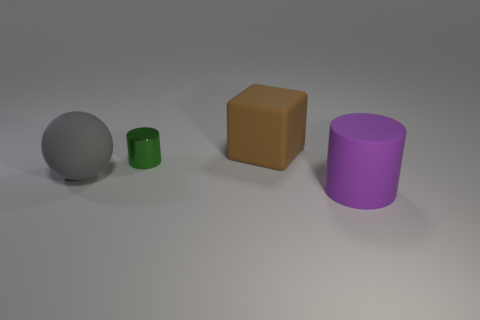Is there any other thing that is the same size as the green shiny object?
Your answer should be very brief. No. Is there any other thing that has the same shape as the gray matte object?
Make the answer very short. No. Do the green object behind the large gray rubber object and the big object that is in front of the big gray ball have the same shape?
Keep it short and to the point. Yes. The big matte object that is left of the cylinder that is left of the brown object is what shape?
Keep it short and to the point. Sphere. What is the size of the matte thing that is in front of the brown thing and on the left side of the large cylinder?
Your answer should be very brief. Large. Is the shape of the purple matte thing the same as the green object that is in front of the big brown rubber block?
Your answer should be very brief. Yes. The other object that is the same shape as the green metallic object is what size?
Your response must be concise. Large. How many other objects are there of the same size as the purple matte cylinder?
Provide a short and direct response. 2. What shape is the large matte object that is in front of the gray rubber ball that is in front of the cylinder that is behind the large purple rubber cylinder?
Provide a succinct answer. Cylinder. Is the size of the block the same as the cylinder that is left of the brown matte cube?
Your answer should be very brief. No. 